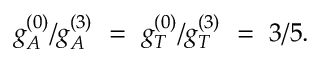Convert formula to latex. <formula><loc_0><loc_0><loc_500><loc_500>g _ { A } ^ { ( 0 ) } / g _ { A } ^ { ( 3 ) } \ = \ g _ { T } ^ { ( 0 ) } / g _ { T } ^ { ( 3 ) } \ = \ 3 / 5 .</formula> 